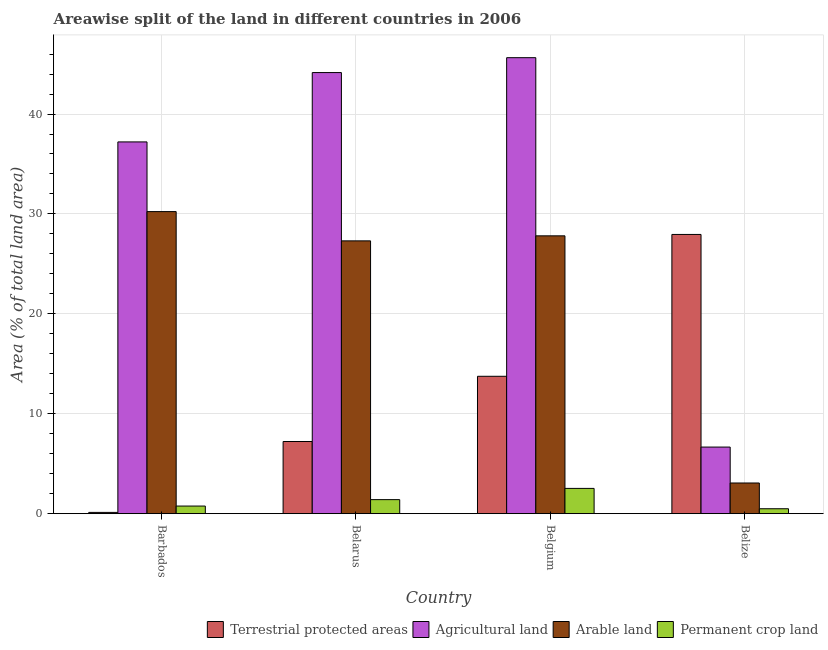How many different coloured bars are there?
Offer a very short reply. 4. Are the number of bars on each tick of the X-axis equal?
Your response must be concise. Yes. How many bars are there on the 3rd tick from the right?
Offer a terse response. 4. What is the label of the 1st group of bars from the left?
Provide a succinct answer. Barbados. In how many cases, is the number of bars for a given country not equal to the number of legend labels?
Offer a very short reply. 0. What is the percentage of area under agricultural land in Belarus?
Make the answer very short. 44.15. Across all countries, what is the maximum percentage of land under terrestrial protection?
Provide a succinct answer. 27.95. Across all countries, what is the minimum percentage of land under terrestrial protection?
Your answer should be compact. 0.12. In which country was the percentage of area under agricultural land maximum?
Offer a terse response. Belgium. In which country was the percentage of area under permanent crop land minimum?
Your answer should be compact. Belize. What is the total percentage of area under arable land in the graph?
Give a very brief answer. 88.41. What is the difference between the percentage of area under permanent crop land in Belgium and that in Belize?
Make the answer very short. 2.04. What is the difference between the percentage of area under permanent crop land in Belarus and the percentage of land under terrestrial protection in Belize?
Offer a terse response. -26.54. What is the average percentage of land under terrestrial protection per country?
Your response must be concise. 12.26. What is the difference between the percentage of land under terrestrial protection and percentage of area under arable land in Belgium?
Ensure brevity in your answer.  -14.06. What is the ratio of the percentage of area under arable land in Barbados to that in Belarus?
Provide a succinct answer. 1.11. What is the difference between the highest and the second highest percentage of area under permanent crop land?
Provide a short and direct response. 1.12. What is the difference between the highest and the lowest percentage of land under terrestrial protection?
Make the answer very short. 27.82. Is the sum of the percentage of area under permanent crop land in Belarus and Belize greater than the maximum percentage of area under agricultural land across all countries?
Provide a short and direct response. No. What does the 1st bar from the left in Barbados represents?
Your response must be concise. Terrestrial protected areas. What does the 4th bar from the right in Barbados represents?
Your answer should be very brief. Terrestrial protected areas. Is it the case that in every country, the sum of the percentage of land under terrestrial protection and percentage of area under agricultural land is greater than the percentage of area under arable land?
Your response must be concise. Yes. How many bars are there?
Keep it short and to the point. 16. Are all the bars in the graph horizontal?
Give a very brief answer. No. What is the difference between two consecutive major ticks on the Y-axis?
Provide a succinct answer. 10. Where does the legend appear in the graph?
Your response must be concise. Bottom right. How many legend labels are there?
Offer a very short reply. 4. How are the legend labels stacked?
Your response must be concise. Horizontal. What is the title of the graph?
Offer a very short reply. Areawise split of the land in different countries in 2006. Does "CO2 damage" appear as one of the legend labels in the graph?
Your answer should be compact. No. What is the label or title of the Y-axis?
Make the answer very short. Area (% of total land area). What is the Area (% of total land area) of Terrestrial protected areas in Barbados?
Ensure brevity in your answer.  0.12. What is the Area (% of total land area) in Agricultural land in Barbados?
Offer a terse response. 37.21. What is the Area (% of total land area) in Arable land in Barbados?
Provide a succinct answer. 30.23. What is the Area (% of total land area) in Permanent crop land in Barbados?
Offer a very short reply. 0.76. What is the Area (% of total land area) in Terrestrial protected areas in Belarus?
Make the answer very short. 7.22. What is the Area (% of total land area) in Agricultural land in Belarus?
Offer a terse response. 44.15. What is the Area (% of total land area) of Arable land in Belarus?
Make the answer very short. 27.3. What is the Area (% of total land area) of Permanent crop land in Belarus?
Your response must be concise. 1.4. What is the Area (% of total land area) of Terrestrial protected areas in Belgium?
Provide a succinct answer. 13.75. What is the Area (% of total land area) in Agricultural land in Belgium?
Your answer should be very brief. 45.64. What is the Area (% of total land area) of Arable land in Belgium?
Make the answer very short. 27.81. What is the Area (% of total land area) in Permanent crop land in Belgium?
Provide a succinct answer. 2.53. What is the Area (% of total land area) of Terrestrial protected areas in Belize?
Give a very brief answer. 27.95. What is the Area (% of total land area) in Agricultural land in Belize?
Provide a short and direct response. 6.66. What is the Area (% of total land area) of Arable land in Belize?
Your answer should be very brief. 3.07. What is the Area (% of total land area) in Permanent crop land in Belize?
Make the answer very short. 0.49. Across all countries, what is the maximum Area (% of total land area) of Terrestrial protected areas?
Your response must be concise. 27.95. Across all countries, what is the maximum Area (% of total land area) in Agricultural land?
Your answer should be very brief. 45.64. Across all countries, what is the maximum Area (% of total land area) in Arable land?
Ensure brevity in your answer.  30.23. Across all countries, what is the maximum Area (% of total land area) in Permanent crop land?
Your answer should be very brief. 2.53. Across all countries, what is the minimum Area (% of total land area) in Terrestrial protected areas?
Give a very brief answer. 0.12. Across all countries, what is the minimum Area (% of total land area) in Agricultural land?
Your response must be concise. 6.66. Across all countries, what is the minimum Area (% of total land area) of Arable land?
Ensure brevity in your answer.  3.07. Across all countries, what is the minimum Area (% of total land area) in Permanent crop land?
Your response must be concise. 0.49. What is the total Area (% of total land area) in Terrestrial protected areas in the graph?
Your response must be concise. 49.04. What is the total Area (% of total land area) of Agricultural land in the graph?
Ensure brevity in your answer.  133.66. What is the total Area (% of total land area) in Arable land in the graph?
Your response must be concise. 88.41. What is the total Area (% of total land area) in Permanent crop land in the graph?
Your answer should be compact. 5.18. What is the difference between the Area (% of total land area) of Terrestrial protected areas in Barbados and that in Belarus?
Offer a very short reply. -7.1. What is the difference between the Area (% of total land area) of Agricultural land in Barbados and that in Belarus?
Ensure brevity in your answer.  -6.94. What is the difference between the Area (% of total land area) in Arable land in Barbados and that in Belarus?
Your response must be concise. 2.93. What is the difference between the Area (% of total land area) in Permanent crop land in Barbados and that in Belarus?
Your answer should be very brief. -0.64. What is the difference between the Area (% of total land area) of Terrestrial protected areas in Barbados and that in Belgium?
Offer a very short reply. -13.62. What is the difference between the Area (% of total land area) of Agricultural land in Barbados and that in Belgium?
Your response must be concise. -8.43. What is the difference between the Area (% of total land area) in Arable land in Barbados and that in Belgium?
Your answer should be compact. 2.43. What is the difference between the Area (% of total land area) in Permanent crop land in Barbados and that in Belgium?
Provide a short and direct response. -1.77. What is the difference between the Area (% of total land area) of Terrestrial protected areas in Barbados and that in Belize?
Offer a very short reply. -27.82. What is the difference between the Area (% of total land area) in Agricultural land in Barbados and that in Belize?
Offer a terse response. 30.55. What is the difference between the Area (% of total land area) in Arable land in Barbados and that in Belize?
Your answer should be compact. 27.16. What is the difference between the Area (% of total land area) in Permanent crop land in Barbados and that in Belize?
Make the answer very short. 0.27. What is the difference between the Area (% of total land area) in Terrestrial protected areas in Belarus and that in Belgium?
Keep it short and to the point. -6.53. What is the difference between the Area (% of total land area) of Agricultural land in Belarus and that in Belgium?
Give a very brief answer. -1.49. What is the difference between the Area (% of total land area) of Arable land in Belarus and that in Belgium?
Your response must be concise. -0.5. What is the difference between the Area (% of total land area) of Permanent crop land in Belarus and that in Belgium?
Provide a short and direct response. -1.12. What is the difference between the Area (% of total land area) of Terrestrial protected areas in Belarus and that in Belize?
Make the answer very short. -20.72. What is the difference between the Area (% of total land area) of Agricultural land in Belarus and that in Belize?
Keep it short and to the point. 37.49. What is the difference between the Area (% of total land area) in Arable land in Belarus and that in Belize?
Provide a succinct answer. 24.24. What is the difference between the Area (% of total land area) in Permanent crop land in Belarus and that in Belize?
Provide a short and direct response. 0.91. What is the difference between the Area (% of total land area) in Terrestrial protected areas in Belgium and that in Belize?
Ensure brevity in your answer.  -14.2. What is the difference between the Area (% of total land area) of Agricultural land in Belgium and that in Belize?
Ensure brevity in your answer.  38.98. What is the difference between the Area (% of total land area) of Arable land in Belgium and that in Belize?
Your response must be concise. 24.74. What is the difference between the Area (% of total land area) of Permanent crop land in Belgium and that in Belize?
Provide a short and direct response. 2.04. What is the difference between the Area (% of total land area) in Terrestrial protected areas in Barbados and the Area (% of total land area) in Agricultural land in Belarus?
Ensure brevity in your answer.  -44.03. What is the difference between the Area (% of total land area) of Terrestrial protected areas in Barbados and the Area (% of total land area) of Arable land in Belarus?
Ensure brevity in your answer.  -27.18. What is the difference between the Area (% of total land area) in Terrestrial protected areas in Barbados and the Area (% of total land area) in Permanent crop land in Belarus?
Make the answer very short. -1.28. What is the difference between the Area (% of total land area) of Agricultural land in Barbados and the Area (% of total land area) of Arable land in Belarus?
Make the answer very short. 9.91. What is the difference between the Area (% of total land area) of Agricultural land in Barbados and the Area (% of total land area) of Permanent crop land in Belarus?
Give a very brief answer. 35.81. What is the difference between the Area (% of total land area) of Arable land in Barbados and the Area (% of total land area) of Permanent crop land in Belarus?
Offer a very short reply. 28.83. What is the difference between the Area (% of total land area) of Terrestrial protected areas in Barbados and the Area (% of total land area) of Agricultural land in Belgium?
Offer a very short reply. -45.52. What is the difference between the Area (% of total land area) of Terrestrial protected areas in Barbados and the Area (% of total land area) of Arable land in Belgium?
Your answer should be compact. -27.68. What is the difference between the Area (% of total land area) of Terrestrial protected areas in Barbados and the Area (% of total land area) of Permanent crop land in Belgium?
Provide a succinct answer. -2.4. What is the difference between the Area (% of total land area) of Agricultural land in Barbados and the Area (% of total land area) of Arable land in Belgium?
Your answer should be very brief. 9.4. What is the difference between the Area (% of total land area) of Agricultural land in Barbados and the Area (% of total land area) of Permanent crop land in Belgium?
Provide a succinct answer. 34.68. What is the difference between the Area (% of total land area) of Arable land in Barbados and the Area (% of total land area) of Permanent crop land in Belgium?
Provide a succinct answer. 27.71. What is the difference between the Area (% of total land area) in Terrestrial protected areas in Barbados and the Area (% of total land area) in Agricultural land in Belize?
Offer a terse response. -6.54. What is the difference between the Area (% of total land area) of Terrestrial protected areas in Barbados and the Area (% of total land area) of Arable land in Belize?
Make the answer very short. -2.94. What is the difference between the Area (% of total land area) of Terrestrial protected areas in Barbados and the Area (% of total land area) of Permanent crop land in Belize?
Keep it short and to the point. -0.37. What is the difference between the Area (% of total land area) of Agricultural land in Barbados and the Area (% of total land area) of Arable land in Belize?
Give a very brief answer. 34.14. What is the difference between the Area (% of total land area) in Agricultural land in Barbados and the Area (% of total land area) in Permanent crop land in Belize?
Provide a succinct answer. 36.72. What is the difference between the Area (% of total land area) of Arable land in Barbados and the Area (% of total land area) of Permanent crop land in Belize?
Make the answer very short. 29.74. What is the difference between the Area (% of total land area) of Terrestrial protected areas in Belarus and the Area (% of total land area) of Agricultural land in Belgium?
Your response must be concise. -38.42. What is the difference between the Area (% of total land area) of Terrestrial protected areas in Belarus and the Area (% of total land area) of Arable land in Belgium?
Keep it short and to the point. -20.59. What is the difference between the Area (% of total land area) in Terrestrial protected areas in Belarus and the Area (% of total land area) in Permanent crop land in Belgium?
Ensure brevity in your answer.  4.69. What is the difference between the Area (% of total land area) in Agricultural land in Belarus and the Area (% of total land area) in Arable land in Belgium?
Your response must be concise. 16.34. What is the difference between the Area (% of total land area) of Agricultural land in Belarus and the Area (% of total land area) of Permanent crop land in Belgium?
Give a very brief answer. 41.62. What is the difference between the Area (% of total land area) of Arable land in Belarus and the Area (% of total land area) of Permanent crop land in Belgium?
Offer a terse response. 24.78. What is the difference between the Area (% of total land area) in Terrestrial protected areas in Belarus and the Area (% of total land area) in Agricultural land in Belize?
Offer a terse response. 0.56. What is the difference between the Area (% of total land area) in Terrestrial protected areas in Belarus and the Area (% of total land area) in Arable land in Belize?
Your answer should be very brief. 4.15. What is the difference between the Area (% of total land area) in Terrestrial protected areas in Belarus and the Area (% of total land area) in Permanent crop land in Belize?
Make the answer very short. 6.73. What is the difference between the Area (% of total land area) of Agricultural land in Belarus and the Area (% of total land area) of Arable land in Belize?
Provide a succinct answer. 41.08. What is the difference between the Area (% of total land area) of Agricultural land in Belarus and the Area (% of total land area) of Permanent crop land in Belize?
Give a very brief answer. 43.66. What is the difference between the Area (% of total land area) of Arable land in Belarus and the Area (% of total land area) of Permanent crop land in Belize?
Give a very brief answer. 26.81. What is the difference between the Area (% of total land area) in Terrestrial protected areas in Belgium and the Area (% of total land area) in Agricultural land in Belize?
Ensure brevity in your answer.  7.08. What is the difference between the Area (% of total land area) of Terrestrial protected areas in Belgium and the Area (% of total land area) of Arable land in Belize?
Your answer should be very brief. 10.68. What is the difference between the Area (% of total land area) of Terrestrial protected areas in Belgium and the Area (% of total land area) of Permanent crop land in Belize?
Make the answer very short. 13.26. What is the difference between the Area (% of total land area) of Agricultural land in Belgium and the Area (% of total land area) of Arable land in Belize?
Make the answer very short. 42.57. What is the difference between the Area (% of total land area) in Agricultural land in Belgium and the Area (% of total land area) in Permanent crop land in Belize?
Offer a very short reply. 45.15. What is the difference between the Area (% of total land area) of Arable land in Belgium and the Area (% of total land area) of Permanent crop land in Belize?
Your response must be concise. 27.32. What is the average Area (% of total land area) of Terrestrial protected areas per country?
Your answer should be compact. 12.26. What is the average Area (% of total land area) in Agricultural land per country?
Make the answer very short. 33.42. What is the average Area (% of total land area) in Arable land per country?
Give a very brief answer. 22.1. What is the average Area (% of total land area) in Permanent crop land per country?
Your answer should be very brief. 1.3. What is the difference between the Area (% of total land area) in Terrestrial protected areas and Area (% of total land area) in Agricultural land in Barbados?
Provide a succinct answer. -37.09. What is the difference between the Area (% of total land area) in Terrestrial protected areas and Area (% of total land area) in Arable land in Barbados?
Make the answer very short. -30.11. What is the difference between the Area (% of total land area) in Terrestrial protected areas and Area (% of total land area) in Permanent crop land in Barbados?
Make the answer very short. -0.64. What is the difference between the Area (% of total land area) in Agricultural land and Area (% of total land area) in Arable land in Barbados?
Your answer should be compact. 6.98. What is the difference between the Area (% of total land area) in Agricultural land and Area (% of total land area) in Permanent crop land in Barbados?
Offer a very short reply. 36.45. What is the difference between the Area (% of total land area) in Arable land and Area (% of total land area) in Permanent crop land in Barbados?
Give a very brief answer. 29.47. What is the difference between the Area (% of total land area) of Terrestrial protected areas and Area (% of total land area) of Agricultural land in Belarus?
Offer a terse response. -36.93. What is the difference between the Area (% of total land area) of Terrestrial protected areas and Area (% of total land area) of Arable land in Belarus?
Your answer should be compact. -20.08. What is the difference between the Area (% of total land area) of Terrestrial protected areas and Area (% of total land area) of Permanent crop land in Belarus?
Provide a short and direct response. 5.82. What is the difference between the Area (% of total land area) in Agricultural land and Area (% of total land area) in Arable land in Belarus?
Your answer should be very brief. 16.85. What is the difference between the Area (% of total land area) in Agricultural land and Area (% of total land area) in Permanent crop land in Belarus?
Offer a very short reply. 42.75. What is the difference between the Area (% of total land area) in Arable land and Area (% of total land area) in Permanent crop land in Belarus?
Offer a very short reply. 25.9. What is the difference between the Area (% of total land area) in Terrestrial protected areas and Area (% of total land area) in Agricultural land in Belgium?
Your answer should be compact. -31.89. What is the difference between the Area (% of total land area) of Terrestrial protected areas and Area (% of total land area) of Arable land in Belgium?
Ensure brevity in your answer.  -14.06. What is the difference between the Area (% of total land area) of Terrestrial protected areas and Area (% of total land area) of Permanent crop land in Belgium?
Offer a very short reply. 11.22. What is the difference between the Area (% of total land area) of Agricultural land and Area (% of total land area) of Arable land in Belgium?
Your response must be concise. 17.83. What is the difference between the Area (% of total land area) of Agricultural land and Area (% of total land area) of Permanent crop land in Belgium?
Offer a very short reply. 43.11. What is the difference between the Area (% of total land area) in Arable land and Area (% of total land area) in Permanent crop land in Belgium?
Your response must be concise. 25.28. What is the difference between the Area (% of total land area) in Terrestrial protected areas and Area (% of total land area) in Agricultural land in Belize?
Ensure brevity in your answer.  21.28. What is the difference between the Area (% of total land area) of Terrestrial protected areas and Area (% of total land area) of Arable land in Belize?
Ensure brevity in your answer.  24.88. What is the difference between the Area (% of total land area) of Terrestrial protected areas and Area (% of total land area) of Permanent crop land in Belize?
Your response must be concise. 27.46. What is the difference between the Area (% of total land area) in Agricultural land and Area (% of total land area) in Arable land in Belize?
Ensure brevity in your answer.  3.59. What is the difference between the Area (% of total land area) of Agricultural land and Area (% of total land area) of Permanent crop land in Belize?
Provide a succinct answer. 6.17. What is the difference between the Area (% of total land area) in Arable land and Area (% of total land area) in Permanent crop land in Belize?
Make the answer very short. 2.58. What is the ratio of the Area (% of total land area) of Terrestrial protected areas in Barbados to that in Belarus?
Offer a very short reply. 0.02. What is the ratio of the Area (% of total land area) of Agricultural land in Barbados to that in Belarus?
Provide a succinct answer. 0.84. What is the ratio of the Area (% of total land area) in Arable land in Barbados to that in Belarus?
Give a very brief answer. 1.11. What is the ratio of the Area (% of total land area) of Permanent crop land in Barbados to that in Belarus?
Your response must be concise. 0.54. What is the ratio of the Area (% of total land area) of Terrestrial protected areas in Barbados to that in Belgium?
Your response must be concise. 0.01. What is the ratio of the Area (% of total land area) of Agricultural land in Barbados to that in Belgium?
Make the answer very short. 0.82. What is the ratio of the Area (% of total land area) in Arable land in Barbados to that in Belgium?
Make the answer very short. 1.09. What is the ratio of the Area (% of total land area) of Permanent crop land in Barbados to that in Belgium?
Provide a succinct answer. 0.3. What is the ratio of the Area (% of total land area) of Terrestrial protected areas in Barbados to that in Belize?
Make the answer very short. 0. What is the ratio of the Area (% of total land area) in Agricultural land in Barbados to that in Belize?
Provide a succinct answer. 5.58. What is the ratio of the Area (% of total land area) in Arable land in Barbados to that in Belize?
Provide a short and direct response. 9.85. What is the ratio of the Area (% of total land area) of Permanent crop land in Barbados to that in Belize?
Keep it short and to the point. 1.55. What is the ratio of the Area (% of total land area) of Terrestrial protected areas in Belarus to that in Belgium?
Provide a succinct answer. 0.53. What is the ratio of the Area (% of total land area) in Agricultural land in Belarus to that in Belgium?
Provide a succinct answer. 0.97. What is the ratio of the Area (% of total land area) of Arable land in Belarus to that in Belgium?
Make the answer very short. 0.98. What is the ratio of the Area (% of total land area) in Permanent crop land in Belarus to that in Belgium?
Offer a terse response. 0.56. What is the ratio of the Area (% of total land area) in Terrestrial protected areas in Belarus to that in Belize?
Ensure brevity in your answer.  0.26. What is the ratio of the Area (% of total land area) in Agricultural land in Belarus to that in Belize?
Your answer should be very brief. 6.63. What is the ratio of the Area (% of total land area) in Arable land in Belarus to that in Belize?
Provide a succinct answer. 8.9. What is the ratio of the Area (% of total land area) in Permanent crop land in Belarus to that in Belize?
Your answer should be compact. 2.86. What is the ratio of the Area (% of total land area) of Terrestrial protected areas in Belgium to that in Belize?
Your response must be concise. 0.49. What is the ratio of the Area (% of total land area) in Agricultural land in Belgium to that in Belize?
Your response must be concise. 6.85. What is the ratio of the Area (% of total land area) of Arable land in Belgium to that in Belize?
Your response must be concise. 9.06. What is the ratio of the Area (% of total land area) in Permanent crop land in Belgium to that in Belize?
Your answer should be compact. 5.15. What is the difference between the highest and the second highest Area (% of total land area) of Terrestrial protected areas?
Provide a succinct answer. 14.2. What is the difference between the highest and the second highest Area (% of total land area) in Agricultural land?
Give a very brief answer. 1.49. What is the difference between the highest and the second highest Area (% of total land area) of Arable land?
Your response must be concise. 2.43. What is the difference between the highest and the second highest Area (% of total land area) of Permanent crop land?
Make the answer very short. 1.12. What is the difference between the highest and the lowest Area (% of total land area) in Terrestrial protected areas?
Your response must be concise. 27.82. What is the difference between the highest and the lowest Area (% of total land area) in Agricultural land?
Keep it short and to the point. 38.98. What is the difference between the highest and the lowest Area (% of total land area) of Arable land?
Your answer should be very brief. 27.16. What is the difference between the highest and the lowest Area (% of total land area) in Permanent crop land?
Keep it short and to the point. 2.04. 